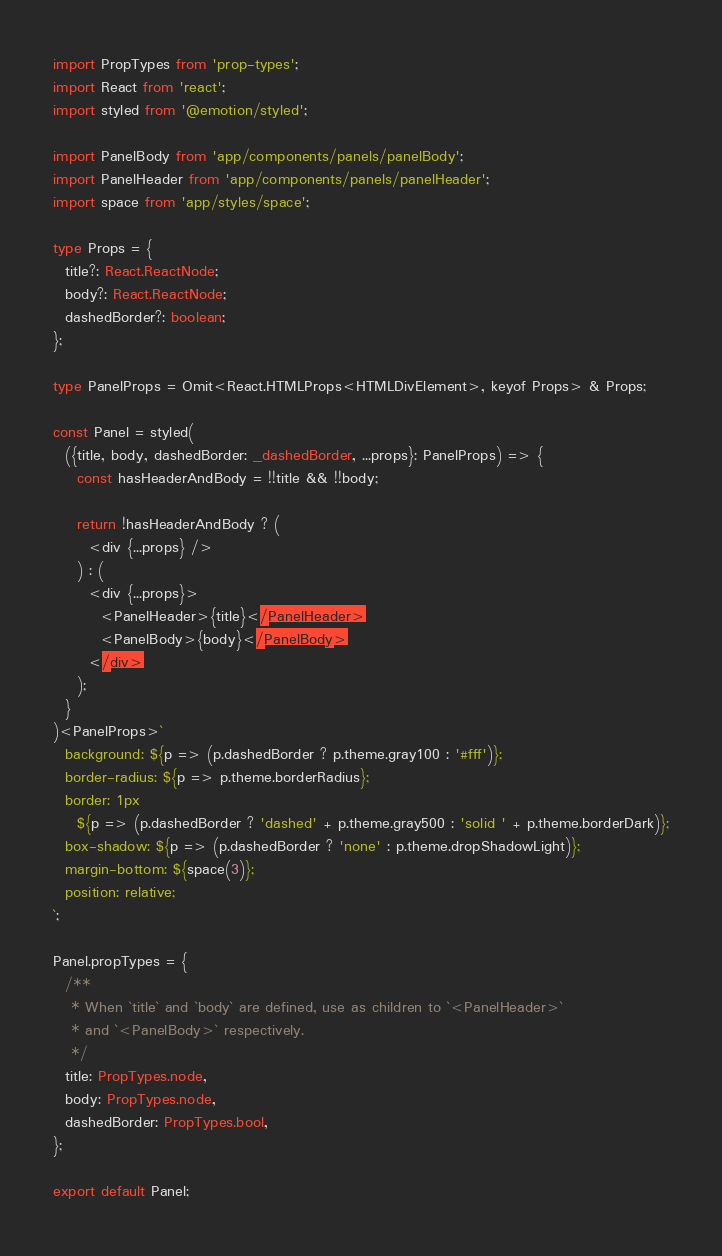Convert code to text. <code><loc_0><loc_0><loc_500><loc_500><_TypeScript_>import PropTypes from 'prop-types';
import React from 'react';
import styled from '@emotion/styled';

import PanelBody from 'app/components/panels/panelBody';
import PanelHeader from 'app/components/panels/panelHeader';
import space from 'app/styles/space';

type Props = {
  title?: React.ReactNode;
  body?: React.ReactNode;
  dashedBorder?: boolean;
};

type PanelProps = Omit<React.HTMLProps<HTMLDivElement>, keyof Props> & Props;

const Panel = styled(
  ({title, body, dashedBorder: _dashedBorder, ...props}: PanelProps) => {
    const hasHeaderAndBody = !!title && !!body;

    return !hasHeaderAndBody ? (
      <div {...props} />
    ) : (
      <div {...props}>
        <PanelHeader>{title}</PanelHeader>
        <PanelBody>{body}</PanelBody>
      </div>
    );
  }
)<PanelProps>`
  background: ${p => (p.dashedBorder ? p.theme.gray100 : '#fff')};
  border-radius: ${p => p.theme.borderRadius};
  border: 1px
    ${p => (p.dashedBorder ? 'dashed' + p.theme.gray500 : 'solid ' + p.theme.borderDark)};
  box-shadow: ${p => (p.dashedBorder ? 'none' : p.theme.dropShadowLight)};
  margin-bottom: ${space(3)};
  position: relative;
`;

Panel.propTypes = {
  /**
   * When `title` and `body` are defined, use as children to `<PanelHeader>`
   * and `<PanelBody>` respectively.
   */
  title: PropTypes.node,
  body: PropTypes.node,
  dashedBorder: PropTypes.bool,
};

export default Panel;
</code> 